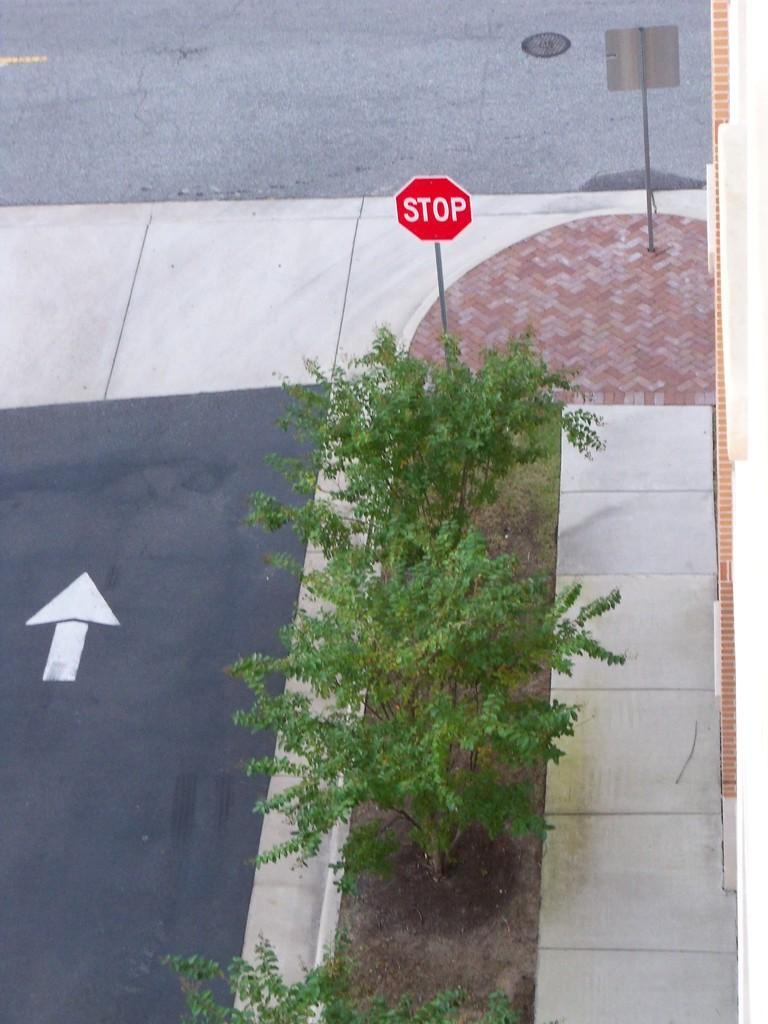<image>
Describe the image concisely. a stop sign that is red in color on the street 